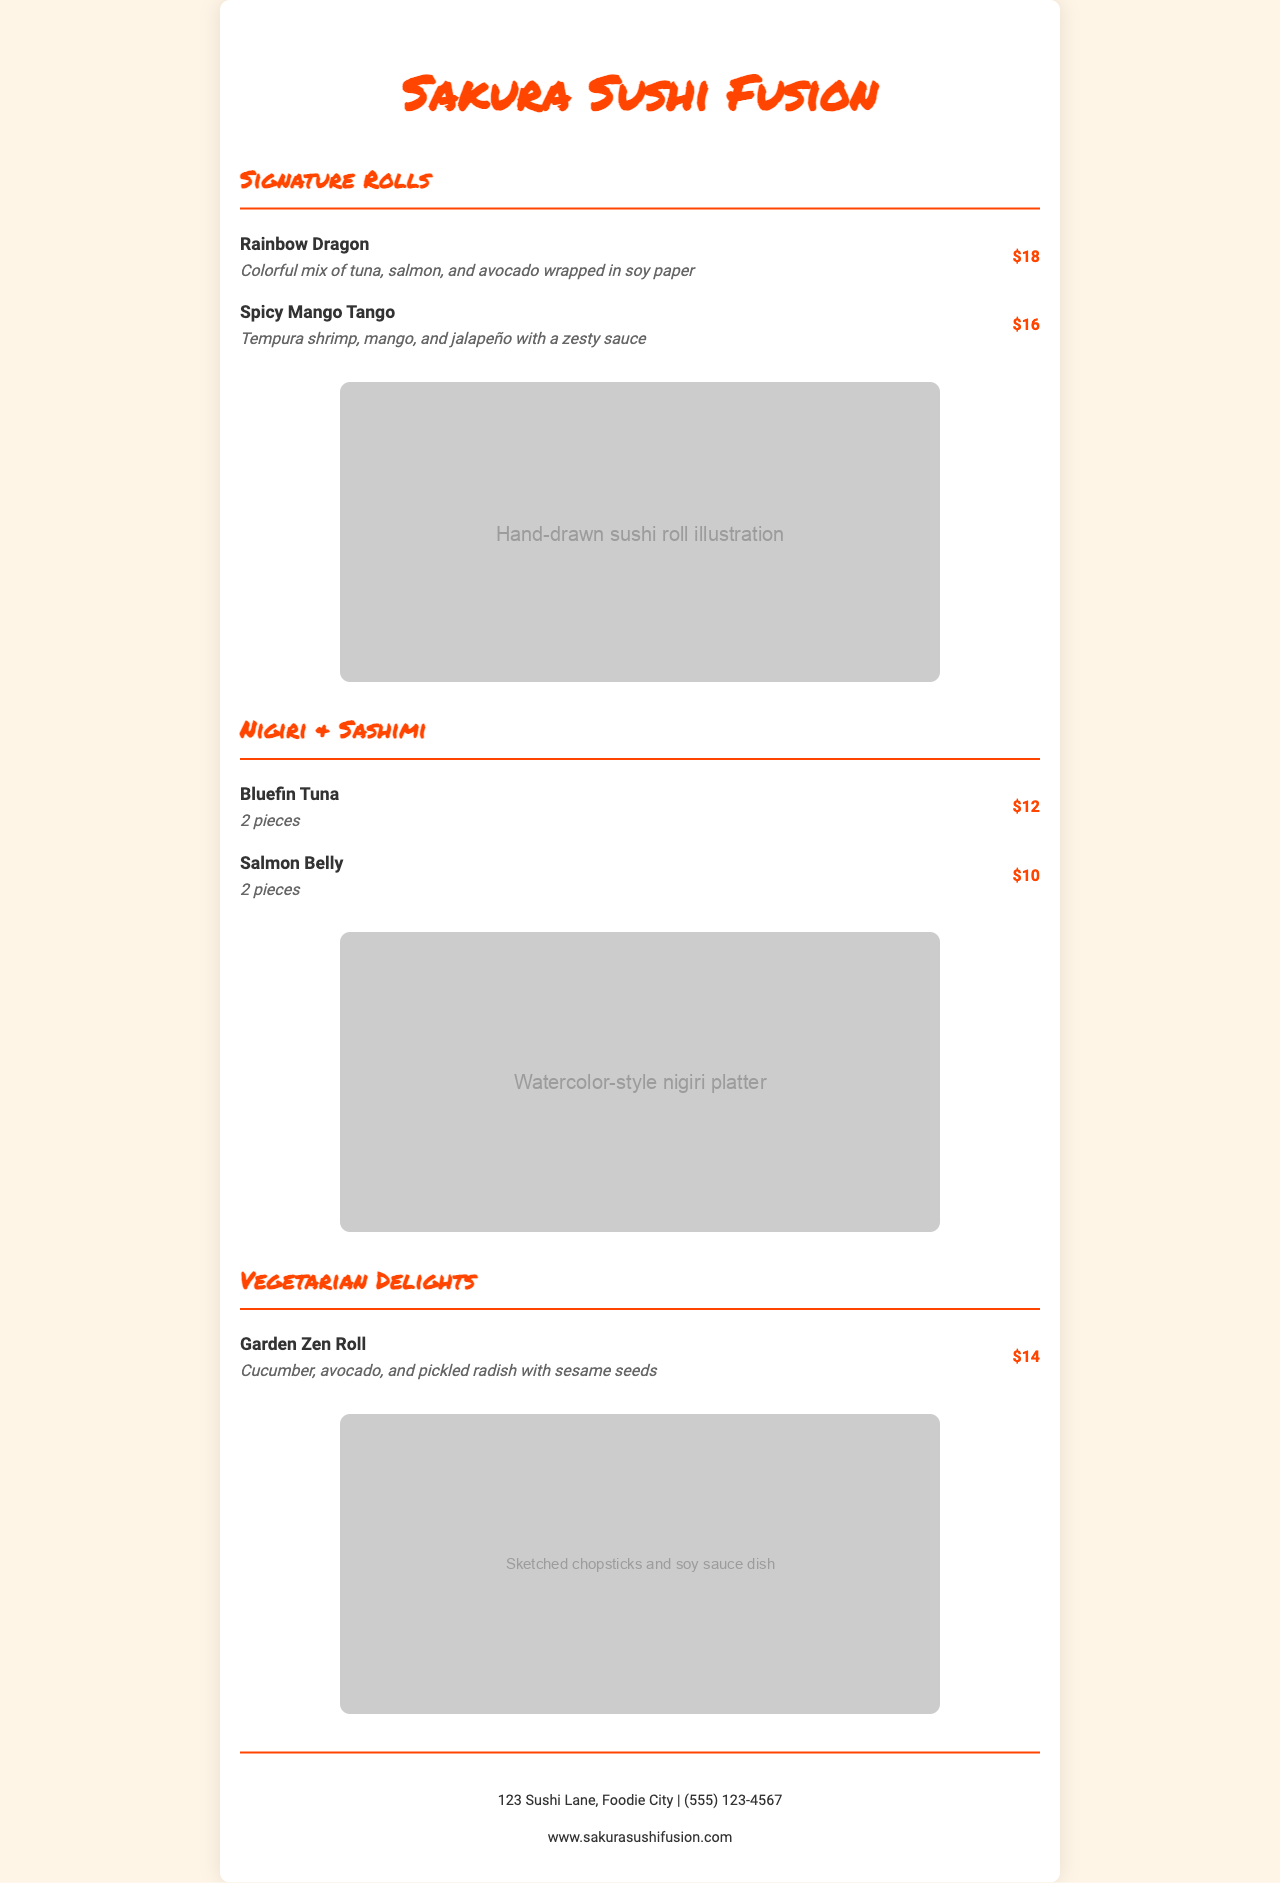What is the name of the sushi restaurant? The name of the restaurant is prominently displayed at the top of the menu.
Answer: Sakura Sushi Fusion How much is the Rainbow Dragon roll? The price for the Rainbow Dragon roll is listed next to its description in the menu.
Answer: $18 What type of fish is featured in the dish Bluefin Tuna? The menu specifies the dish's main ingredient, helping customers know what to expect.
Answer: Tuna How many pieces come with the Salmon Belly dish? The menu states the quantity of pieces for each dish directly in the description.
Answer: 2 pieces What ingredient is included in the Garden Zen Roll? The description of the Garden Zen Roll lists three specific ingredients.
Answer: Cucumber Which roll has a zesty sauce? The description provides key details on the flavor profile of the Spicy Mango Tango roll.
Answer: Spicy Mango Tango What color is the restaurant's primary heading text? The color of the main heading can be identified from the style and design elements presented in the document.
Answer: #FF4500 What is the contact number for the restaurant? The footer of the menu contains the restaurant's contact information clearly listed.
Answer: (555) 123-4567 What type of illustration is associated with the nigiri section? The document specifies the type of illustration provided for the nigiri section, adding visual appeal.
Answer: Watercolor-style nigiri platter 